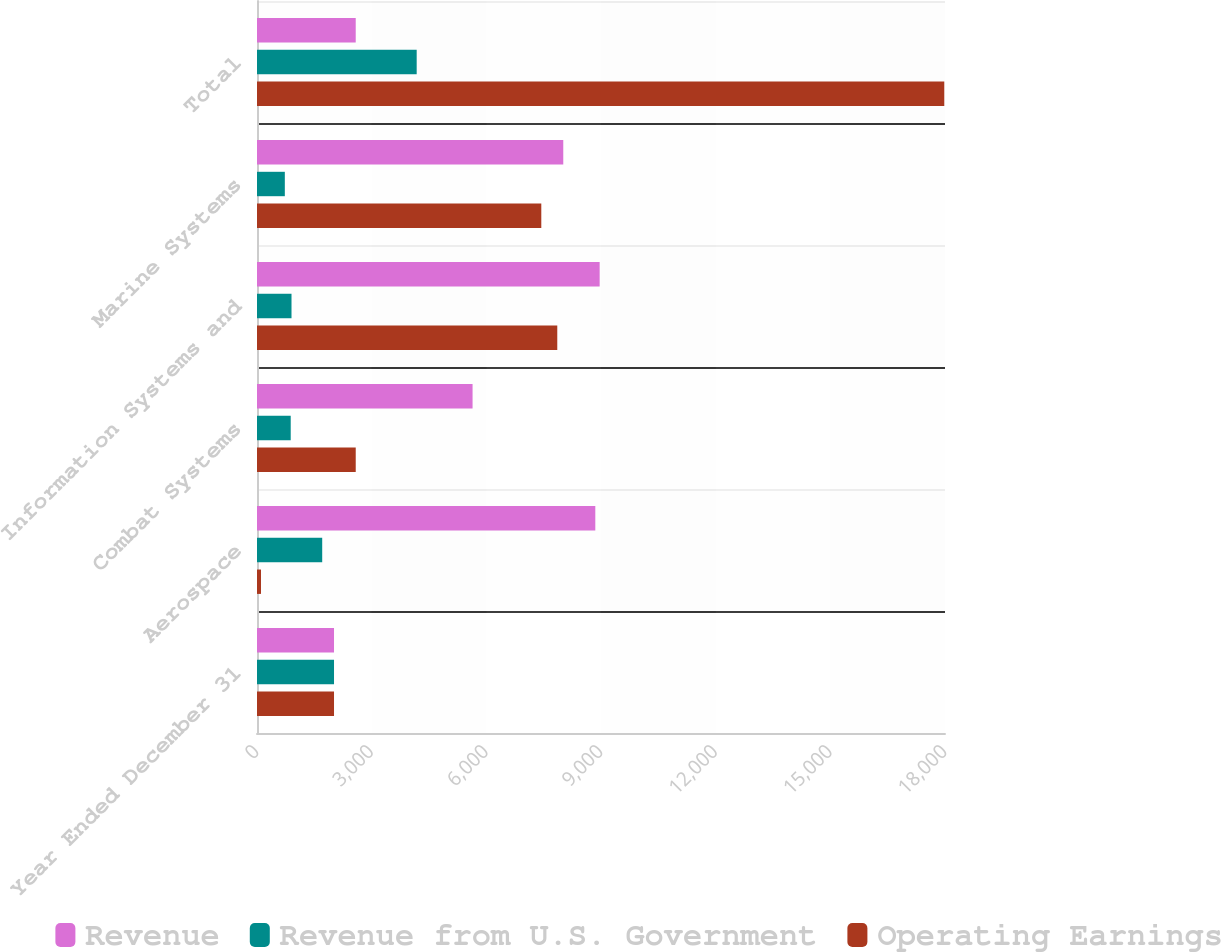Convert chart to OTSL. <chart><loc_0><loc_0><loc_500><loc_500><stacked_bar_chart><ecel><fcel>Year Ended December 31<fcel>Aerospace<fcel>Combat Systems<fcel>Information Systems and<fcel>Marine Systems<fcel>Total<nl><fcel>Revenue<fcel>2015<fcel>8851<fcel>5640<fcel>8965<fcel>8013<fcel>2583<nl><fcel>Revenue from U.S. Government<fcel>2015<fcel>1706<fcel>882<fcel>903<fcel>728<fcel>4178<nl><fcel>Operating Earnings<fcel>2015<fcel>104<fcel>2583<fcel>7856<fcel>7438<fcel>17981<nl></chart> 